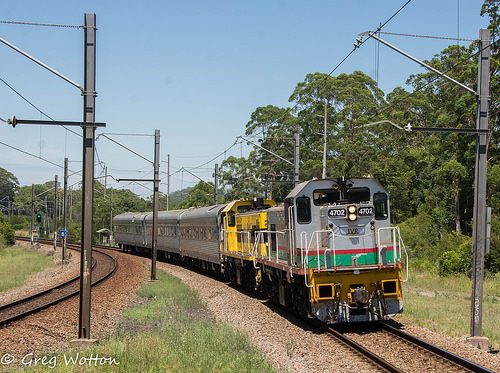<image>
Is there a train next to the post? Yes. The train is positioned adjacent to the post, located nearby in the same general area. Where is the train in relation to the tracks? Is it on the tracks? No. The train is not positioned on the tracks. They may be near each other, but the train is not supported by or resting on top of the tracks. Is there a train to the right of the pole? No. The train is not to the right of the pole. The horizontal positioning shows a different relationship. 